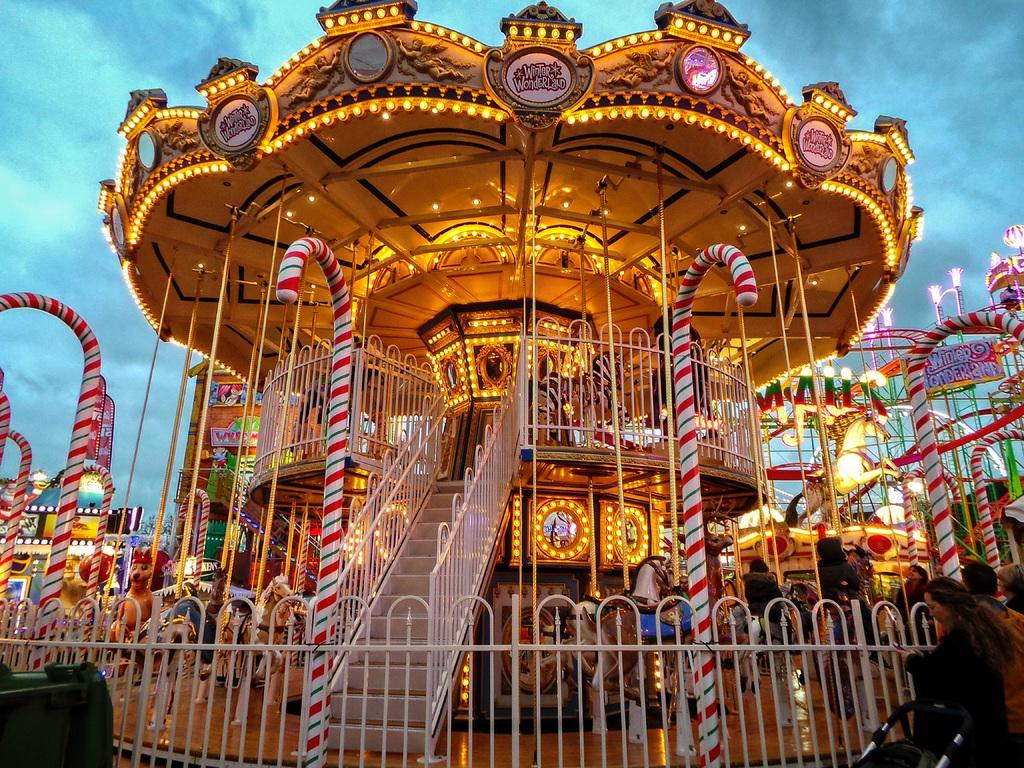Describe this image in one or two sentences. In the picture I can see horse carousel, fence, lights and some other objects. In the background I can see the sky. 